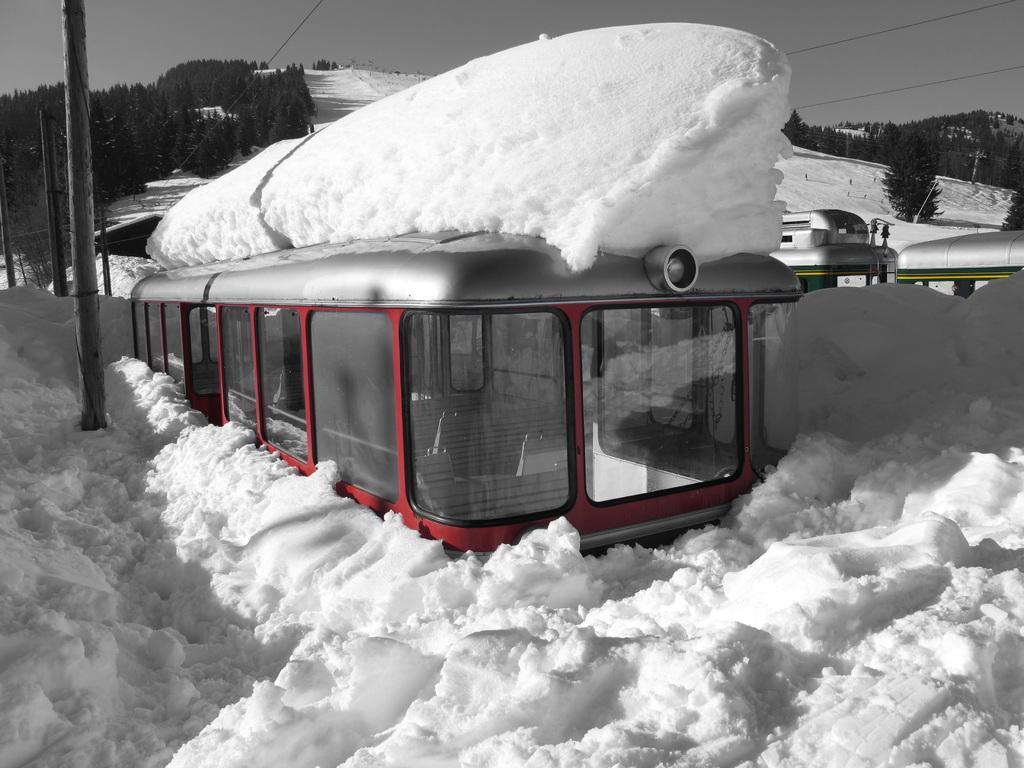Can you describe this image briefly? In the foreground of the picture there are vehicle, pole and snow. In the center of the picture there are trees, poles, vehicles and snow. At the top it is sky and there are cables also. 